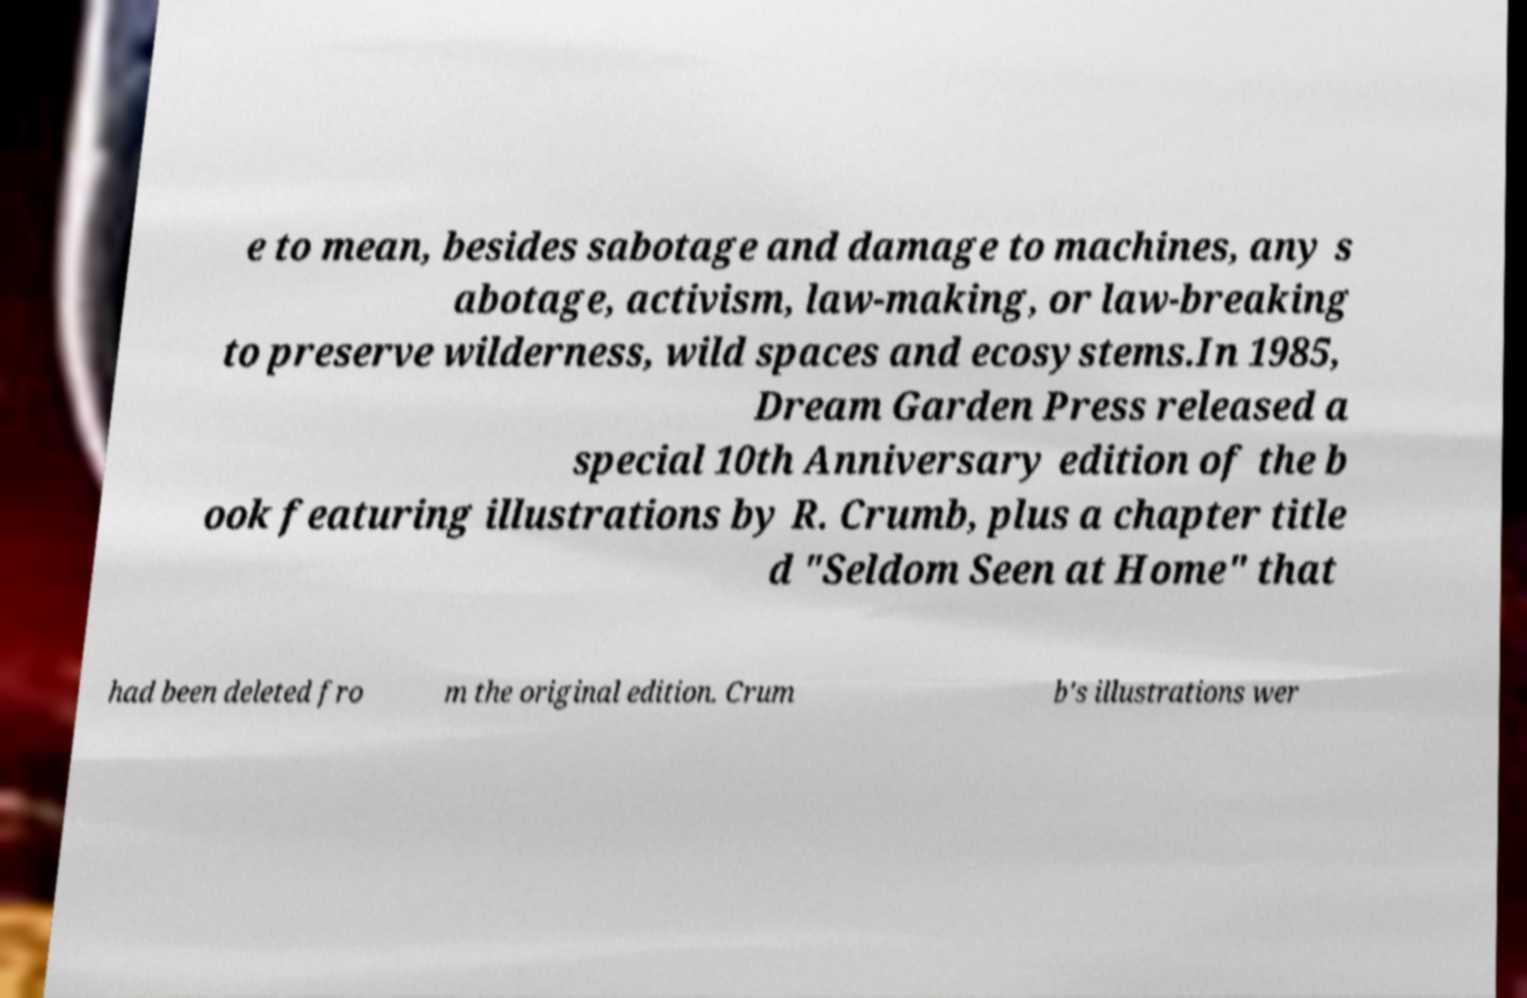What messages or text are displayed in this image? I need them in a readable, typed format. e to mean, besides sabotage and damage to machines, any s abotage, activism, law-making, or law-breaking to preserve wilderness, wild spaces and ecosystems.In 1985, Dream Garden Press released a special 10th Anniversary edition of the b ook featuring illustrations by R. Crumb, plus a chapter title d "Seldom Seen at Home" that had been deleted fro m the original edition. Crum b's illustrations wer 